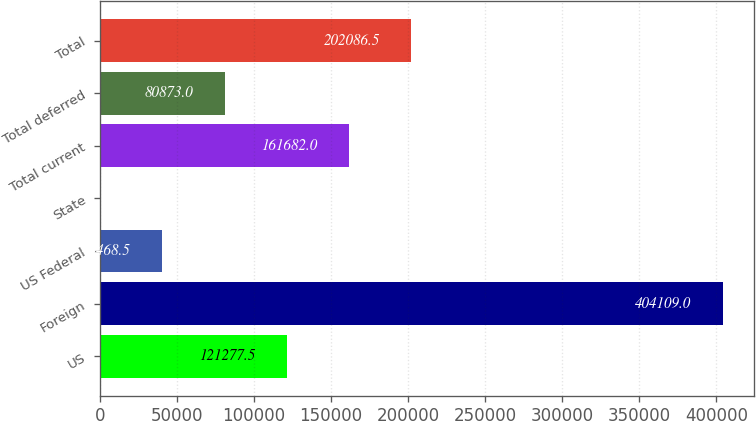Convert chart. <chart><loc_0><loc_0><loc_500><loc_500><bar_chart><fcel>US<fcel>Foreign<fcel>US Federal<fcel>State<fcel>Total current<fcel>Total deferred<fcel>Total<nl><fcel>121278<fcel>404109<fcel>40468.5<fcel>64<fcel>161682<fcel>80873<fcel>202086<nl></chart> 